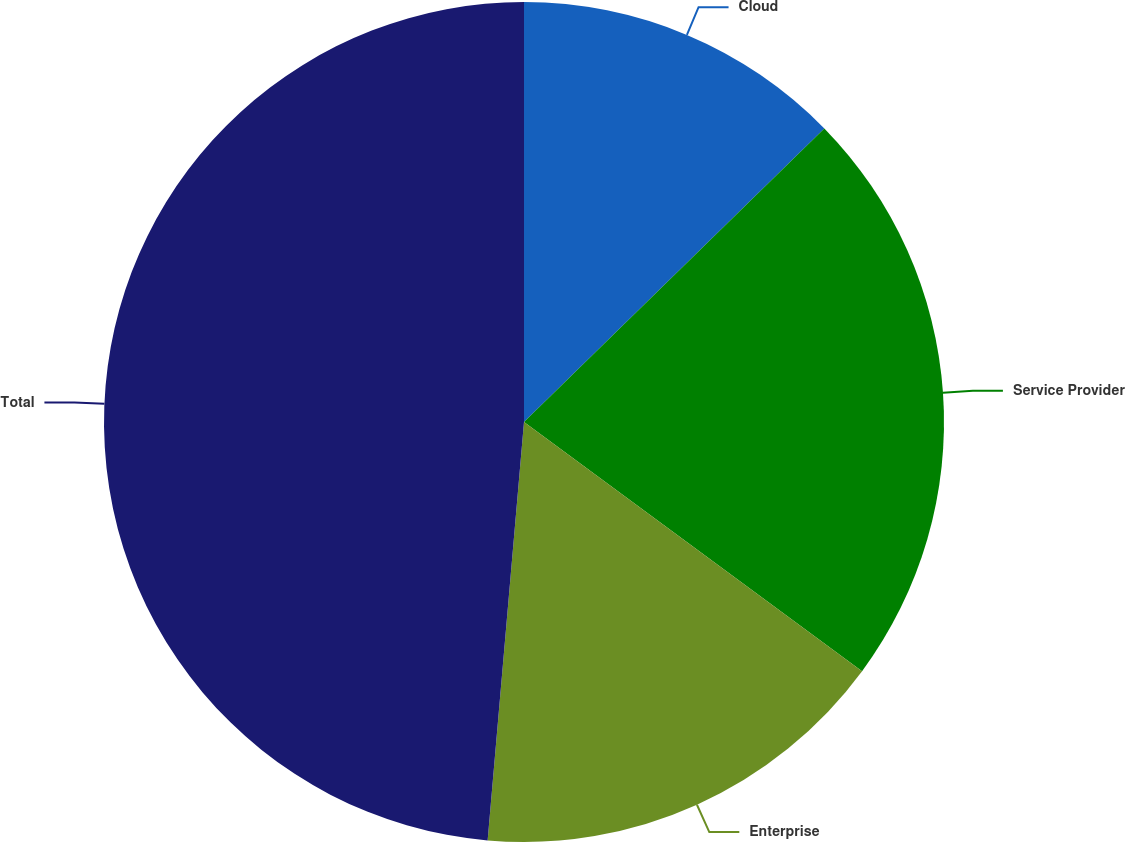<chart> <loc_0><loc_0><loc_500><loc_500><pie_chart><fcel>Cloud<fcel>Service Provider<fcel>Enterprise<fcel>Total<nl><fcel>12.68%<fcel>22.43%<fcel>16.27%<fcel>48.62%<nl></chart> 